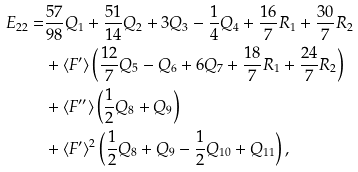<formula> <loc_0><loc_0><loc_500><loc_500>E _ { 2 2 } = & \frac { 5 7 } { 9 8 } Q _ { 1 } + \frac { 5 1 } { 1 4 } Q _ { 2 } + 3 Q _ { 3 } - \frac { 1 } { 4 } Q _ { 4 } + \frac { 1 6 } { 7 } R _ { 1 } + \frac { 3 0 } { 7 } R _ { 2 } \\ & + \langle F ^ { \prime } \rangle \left ( \frac { 1 2 } { 7 } Q _ { 5 } - Q _ { 6 } + 6 Q _ { 7 } + \frac { 1 8 } { 7 } R _ { 1 } + \frac { 2 4 } { 7 } R _ { 2 } \right ) \\ & + \langle F ^ { \prime \prime } \rangle \left ( \frac { 1 } { 2 } Q _ { 8 } + Q _ { 9 } \right ) \\ & + \langle F ^ { \prime } \rangle ^ { 2 } \left ( \frac { 1 } { 2 } Q _ { 8 } + Q _ { 9 } - \frac { 1 } { 2 } Q _ { 1 0 } + Q _ { 1 1 } \right ) ,</formula> 